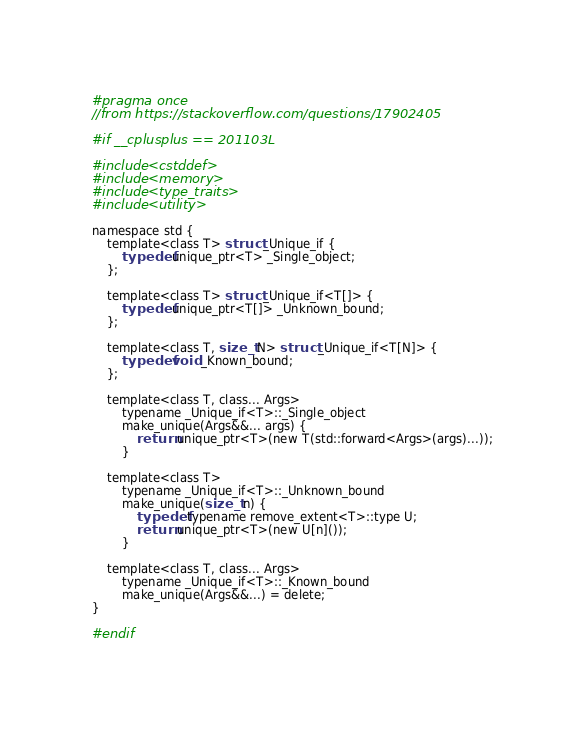<code> <loc_0><loc_0><loc_500><loc_500><_C_>#pragma once
//from https://stackoverflow.com/questions/17902405

#if __cplusplus == 201103L

#include <cstddef>
#include <memory>
#include <type_traits>
#include <utility>

namespace std {
    template<class T> struct _Unique_if {
        typedef unique_ptr<T> _Single_object;
    };

    template<class T> struct _Unique_if<T[]> {
        typedef unique_ptr<T[]> _Unknown_bound;
    };

    template<class T, size_t N> struct _Unique_if<T[N]> {
        typedef void _Known_bound;
    };

    template<class T, class... Args>
        typename _Unique_if<T>::_Single_object
        make_unique(Args&&... args) {
            return unique_ptr<T>(new T(std::forward<Args>(args)...));
        }

    template<class T>
        typename _Unique_if<T>::_Unknown_bound
        make_unique(size_t n) {
            typedef typename remove_extent<T>::type U;
            return unique_ptr<T>(new U[n]());
        }

    template<class T, class... Args>
        typename _Unique_if<T>::_Known_bound
        make_unique(Args&&...) = delete;
}

#endif
</code> 